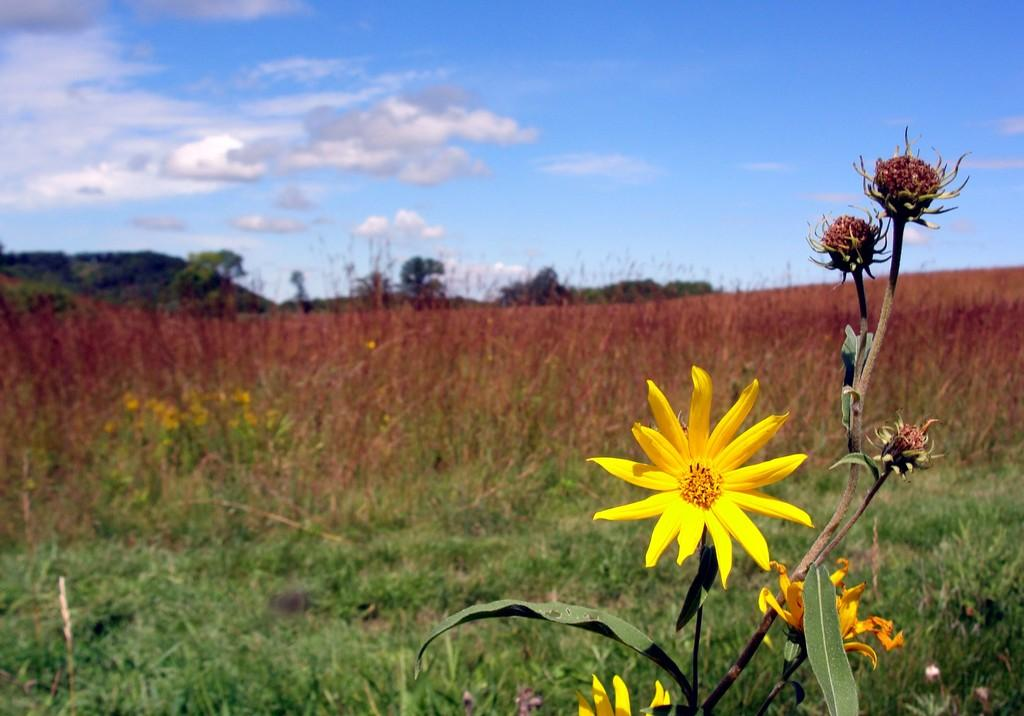What type of vegetation can be seen on a plant in the image? There are flowers on a plant in the image. Are there any other plants visible in the image? Yes, there are other plants visible in the image. What type of ground cover is present in the image? Grass is present in the image. What type of larger vegetation is visible in the image? Trees are visible in the image. How would you describe the sky in the image? The sky appears to be cloudy in the image. Can you tell me how many boats are docked in the harbor in the image? There is no harbor or boats present in the image; it features flowers, plants, grass, trees, and a cloudy sky. What type of creature is shown sleeping on the grass in the image? There is no creature shown sleeping on the grass in the image; it only features plants, grass, trees, and a cloudy sky. 